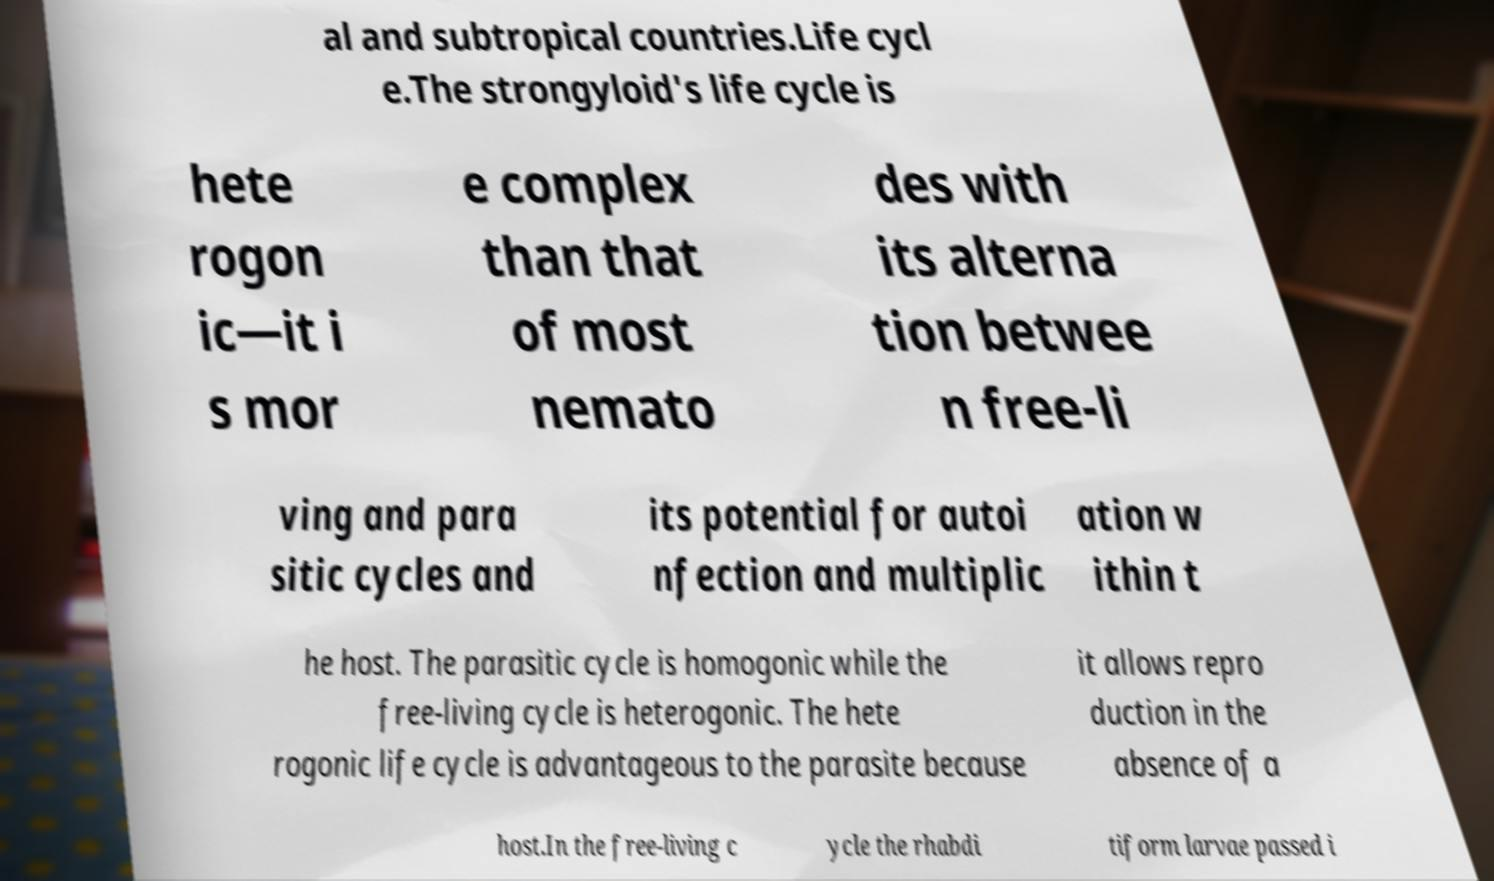Could you assist in decoding the text presented in this image and type it out clearly? al and subtropical countries.Life cycl e.The strongyloid's life cycle is hete rogon ic—it i s mor e complex than that of most nemato des with its alterna tion betwee n free-li ving and para sitic cycles and its potential for autoi nfection and multiplic ation w ithin t he host. The parasitic cycle is homogonic while the free-living cycle is heterogonic. The hete rogonic life cycle is advantageous to the parasite because it allows repro duction in the absence of a host.In the free-living c ycle the rhabdi tiform larvae passed i 